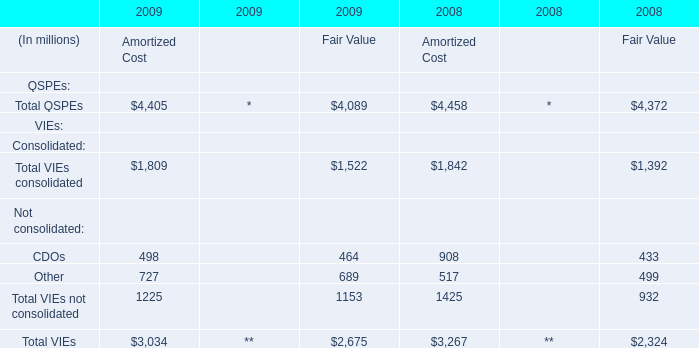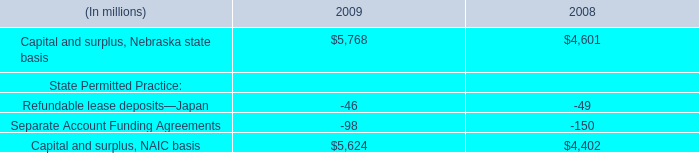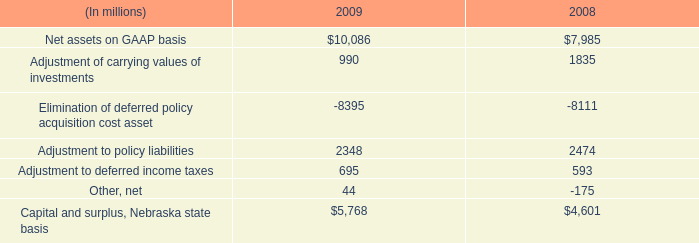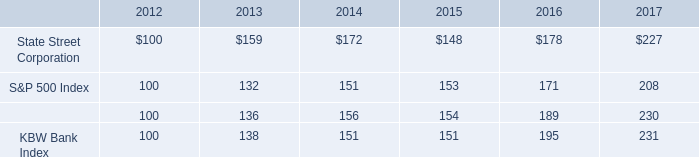What's the increasing rate of Amortized Cost in 2009? (in %) 
Computations: (((((4405 + 1809) + 1225) + 3034) - (((4458 + 1842) + 1425) + 3267)) / (((4458 + 1842) + 1425) + 3267))
Answer: -0.04722. 